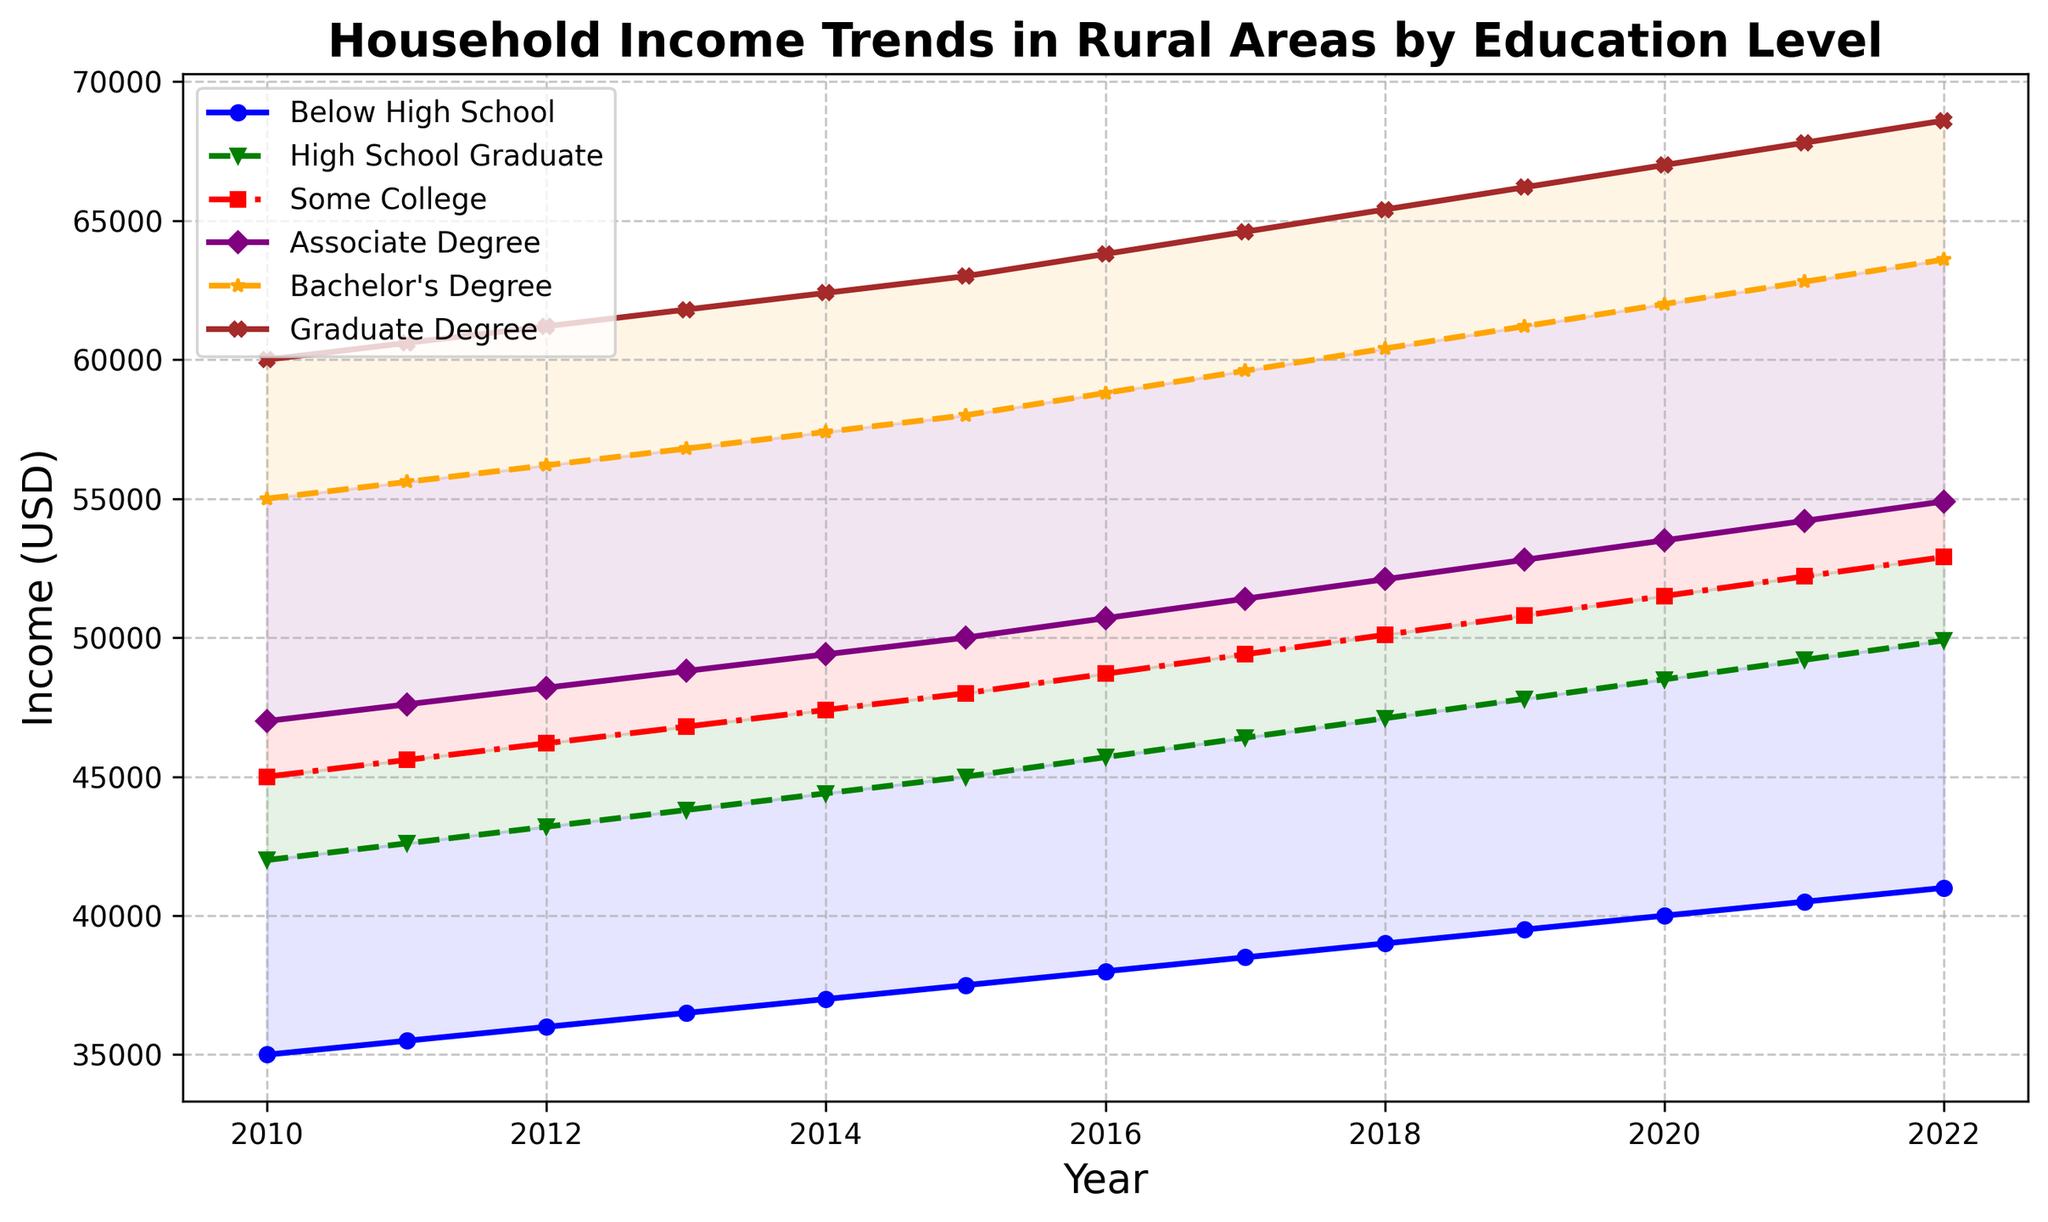Which education level had the highest income in 2022? By looking at the endpoint of each line in 2022, the line representing "Graduate Degree" is the highest, indicating the highest income for that education level.
Answer: Graduate Degree How did the income for "Associate Degree" and "Bachelor's Degree" change from 2010 to 2022? Subtract the income of each education level in 2010 from their income in 2022. For "Associate Degree," it is 54900 - 47000 = 7900. For "Bachelor's Degree," it is 63600 - 55000 = 8600.
Answer: Associate Degree: 7900, Bachelor's Degree: 8600 What is the average income for "High School Graduate" over the years shown? Add the incomes for "High School Graduate" from 2010 to 2022 and divide by the number of years: (42000 + 42600 + 43200 + 43800 + 44400 + 45000 + 45700 + 46400 + 47100 + 47800 + 48500 + 49200 + 49900) / 13. The sum is 614100, so the average is 614100 / 13 = 47238.46.
Answer: 47238.46 Which education level showed the most consistent increase in income over the given period? Observing the smoothness and consistency of the slopes of the lines, all levels show a steady increase. However, "Graduate Degree" consistently increases by around 600 each year without any sudden changes.
Answer: Graduate Degree Which two education levels had the smallest income difference in 2015? Subtracting incomes of each pair for 2015 and finding the smallest difference: 
1. Below High School and High School Graduate: 45000 - 37500 = 7500 
2. Below High School and Some College: 48000 - 37500 = 10500 
3. High School Graduate and Some College: 48000 - 45000 = 3000 (smallest difference). 
Perform similar calculations for other pairs and years ensuring "High School Graduate" and "Some College" show the smallest difference.
Answer: High School Graduate and Some College In which year did "Some College" surpass the $50,000 income mark? Trace the line representing "Some College" to find when it crosses the $50,000 mark. This occurs shortly after 2017 and before 2019, confirming 2018.
Answer: 2018 By roughly how much did the income for "Below High School" and "Graduate Degree" differ in 2012? Subtract income for "Below High School" and "Graduate Degree" in 2012: 61200 - 36000 = 25200.
Answer: 25200 Compare the slope of the line for "Below High School" to "Graduate Degree". Which is steeper? By visually comparing the angles (slopes) of the lines, "Graduate Degree" shows a steeper upward trend than "Below High School", indicating a faster increase in income.
Answer: Graduate Degree What is the estimated difference in income between "Bachelor's Degree" and "High School Graduate" in 2020? Subtract income of "High School Graduate" from "Bachelor's Degree" in 2020: 62000 - 48500 = 13500.
Answer: 13500 